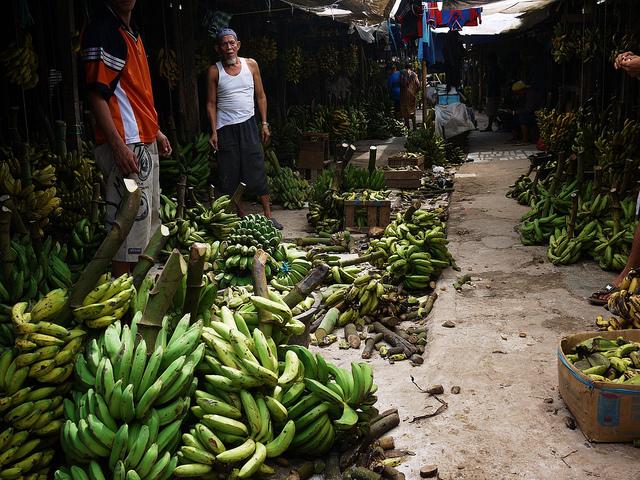How ripe are these bananas?
Concise answer only. Not ripe. What are these men doing?
Keep it brief. Farming bananas. How many bunches are on the ground?
Give a very brief answer. Many. What type of fruit is in the bucket?
Concise answer only. Bananas. What kind of fruit is in this scene?
Keep it brief. Bananas. Are bananas arranged to sell?
Write a very short answer. Yes. 